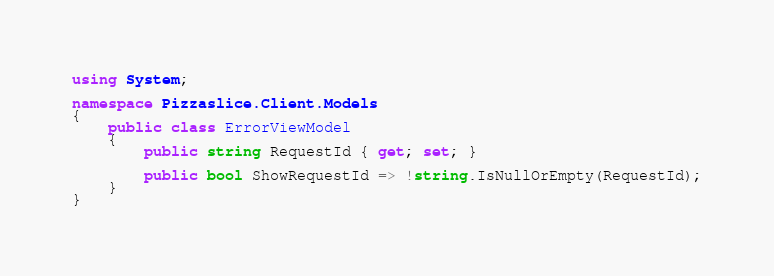<code> <loc_0><loc_0><loc_500><loc_500><_C#_>using System;

namespace Pizzaslice.Client.Models
{
    public class ErrorViewModel
    {
        public string RequestId { get; set; }

        public bool ShowRequestId => !string.IsNullOrEmpty(RequestId);
    }
}</code> 